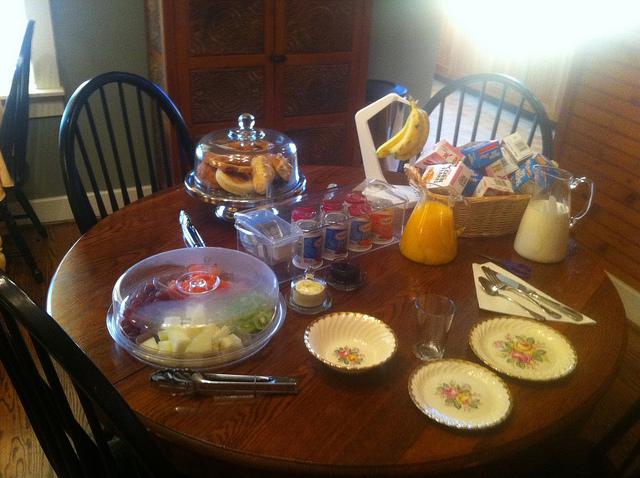What utensils are on the table?
Answer briefly. Knife, fork and spoon. How many plates are on the table?
Be succinct. 3. What is in the container?
Keep it brief. Fruit. 